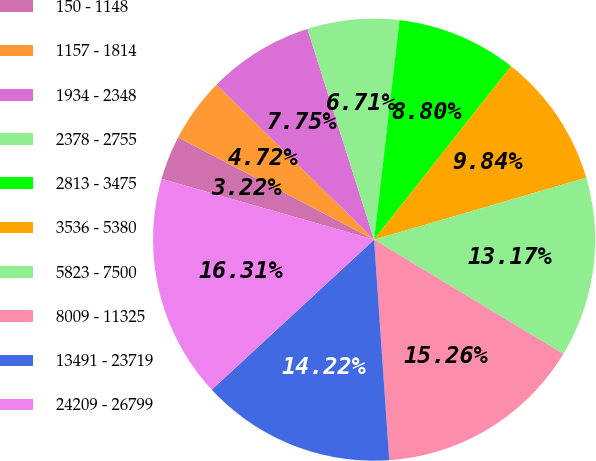Convert chart to OTSL. <chart><loc_0><loc_0><loc_500><loc_500><pie_chart><fcel>150 - 1148<fcel>1157 - 1814<fcel>1934 - 2348<fcel>2378 - 2755<fcel>2813 - 3475<fcel>3536 - 5380<fcel>5823 - 7500<fcel>8009 - 11325<fcel>13491 - 23719<fcel>24209 - 26799<nl><fcel>3.22%<fcel>4.72%<fcel>7.75%<fcel>6.71%<fcel>8.8%<fcel>9.84%<fcel>13.17%<fcel>15.26%<fcel>14.22%<fcel>16.31%<nl></chart> 